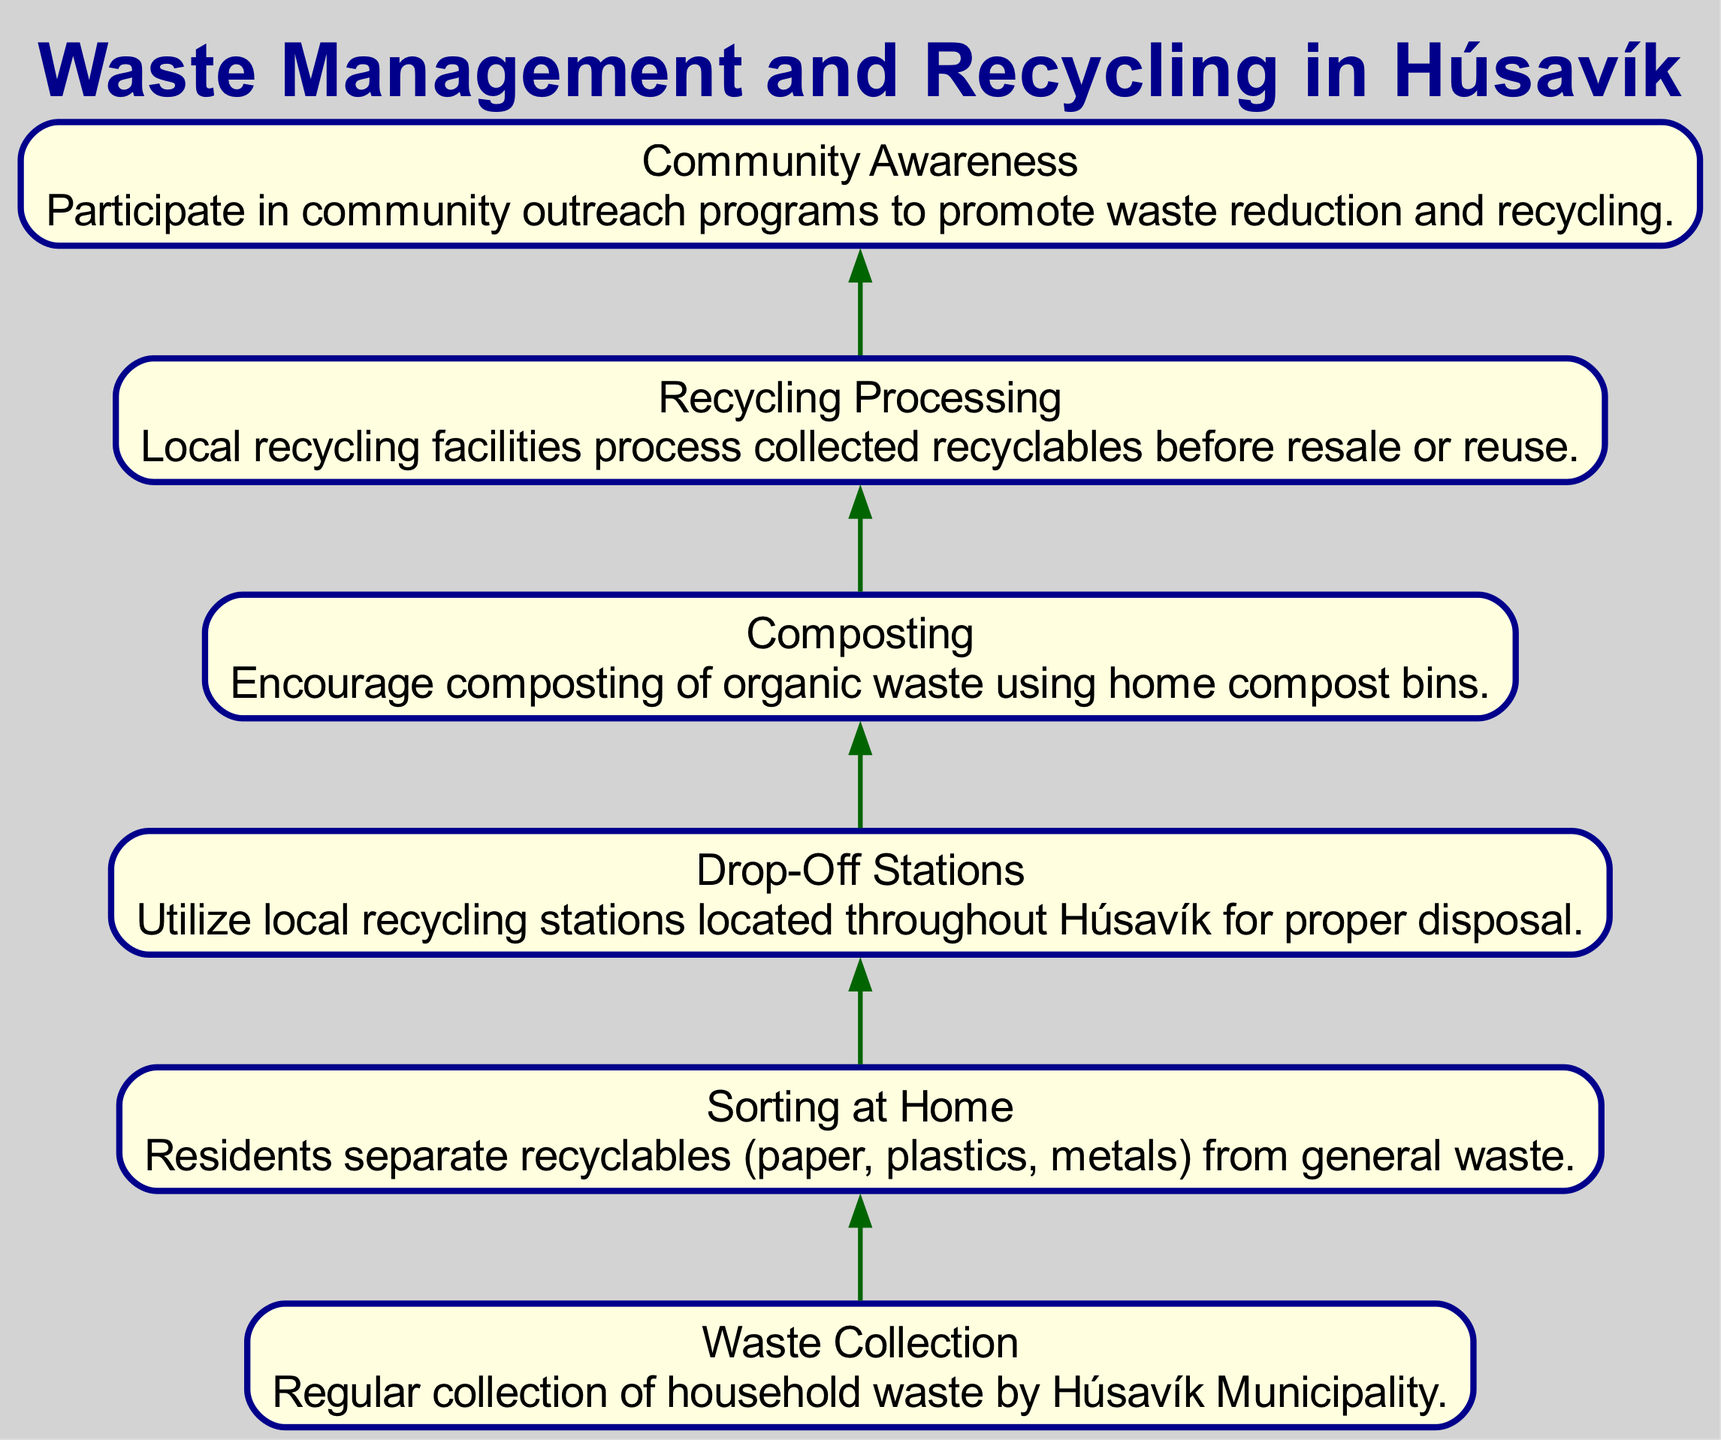What is the first step in the waste management process? The first step is "Waste Collection," which involves the regular collection of household waste by Húsavík Municipality.
Answer: Waste Collection How many steps are listed in the diagram? There are six steps mentioned in the flow chart outlining the waste management process in Húsavík.
Answer: Six What is encouraged as the fourth step? The fourth step encourages "Composting" of organic waste using home compost bins.
Answer: Composting What is the relationship between "Sorting at Home" and "Drop-Off Stations"? "Sorting at Home" leads to the use of "Drop-Off Stations" as residents first separate recyclables and then dispose of them at the recycling stations.
Answer: Leading to Which step comes after "Recycling Processing"? After "Recycling Processing," the next step is "Community Awareness," which involves participating in outreach programs to promote waste reduction and recycling.
Answer: Community Awareness What is the main focus of the "Community Awareness" step? The focus is on promoting waste reduction and recycling through community outreach programs.
Answer: Promoting waste reduction and recycling 